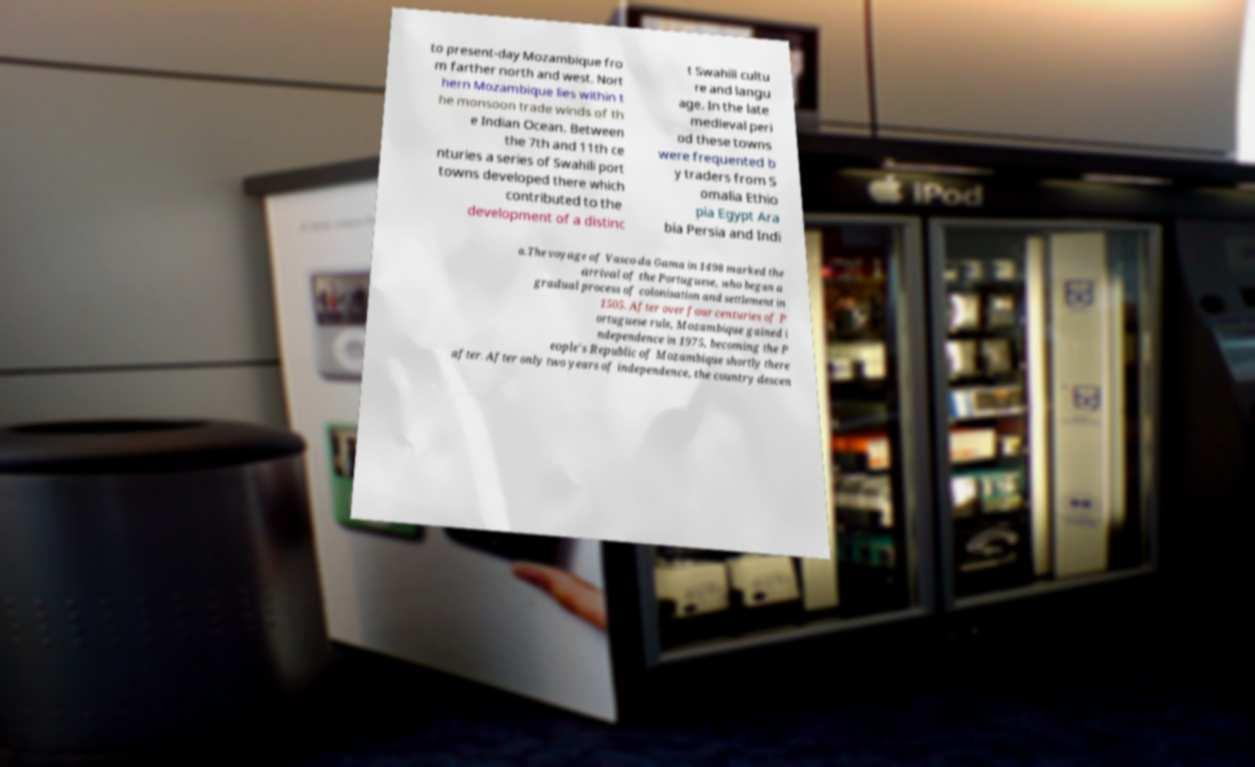Can you read and provide the text displayed in the image?This photo seems to have some interesting text. Can you extract and type it out for me? to present-day Mozambique fro m farther north and west. Nort hern Mozambique lies within t he monsoon trade winds of th e Indian Ocean. Between the 7th and 11th ce nturies a series of Swahili port towns developed there which contributed to the development of a distinc t Swahili cultu re and langu age. In the late medieval peri od these towns were frequented b y traders from S omalia Ethio pia Egypt Ara bia Persia and Indi a.The voyage of Vasco da Gama in 1498 marked the arrival of the Portuguese, who began a gradual process of colonisation and settlement in 1505. After over four centuries of P ortuguese rule, Mozambique gained i ndependence in 1975, becoming the P eople's Republic of Mozambique shortly there after. After only two years of independence, the country descen 